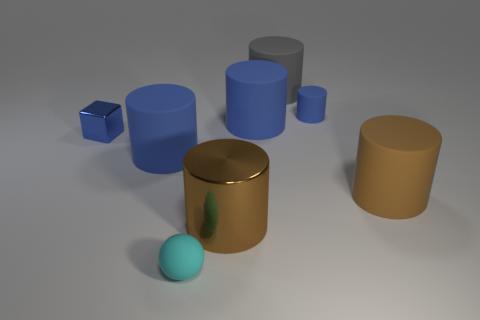Subtract all gray rubber cylinders. How many cylinders are left? 5 Subtract all yellow balls. How many brown cylinders are left? 2 Subtract all gray cylinders. How many cylinders are left? 5 Add 1 red metallic cubes. How many objects exist? 9 Subtract all balls. How many objects are left? 7 Add 8 small cyan matte balls. How many small cyan matte balls are left? 9 Add 7 tiny blue objects. How many tiny blue objects exist? 9 Subtract 0 yellow cubes. How many objects are left? 8 Subtract all brown cylinders. Subtract all brown spheres. How many cylinders are left? 4 Subtract all yellow cylinders. Subtract all matte things. How many objects are left? 2 